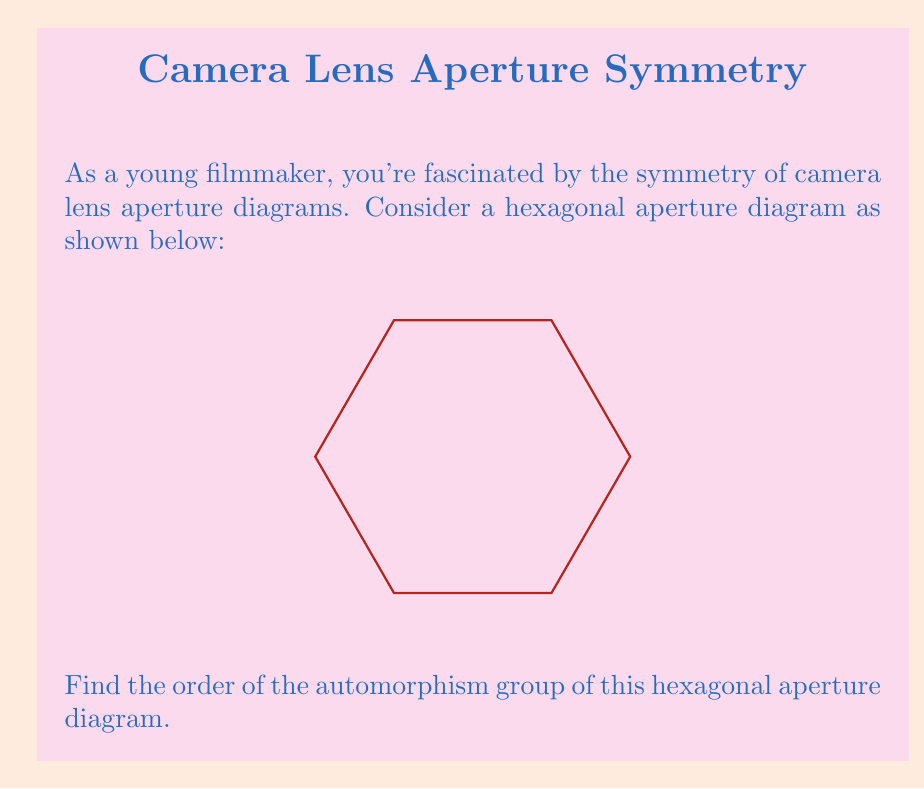Show me your answer to this math problem. To solve this problem, let's follow these steps:

1) First, recall that the automorphism group of a geometric figure consists of all symmetries that preserve the structure of the figure.

2) For a regular hexagon, there are two types of symmetries:
   a) Rotational symmetries
   b) Reflection symmetries

3) Rotational symmetries:
   - The hexagon can be rotated by 60°, 120°, 180°, 240°, 300°, and 360° (which is equivalent to no rotation).
   - This gives us 6 rotational symmetries.

4) Reflection symmetries:
   - There are 6 lines of reflection in a regular hexagon:
     * 3 passing through opposite vertices
     * 3 passing through the midpoints of opposite sides
   - This gives us 6 reflection symmetries.

5) The total number of symmetries is the sum of rotational and reflection symmetries:
   $$ 6 + 6 = 12 $$

6) In group theory, the number of elements in a group is called its order.

Therefore, the order of the automorphism group of the hexagonal aperture diagram is 12.

This group is isomorphic to the dihedral group $D_6$, which is the symmetry group of a regular hexagon.
Answer: 12 